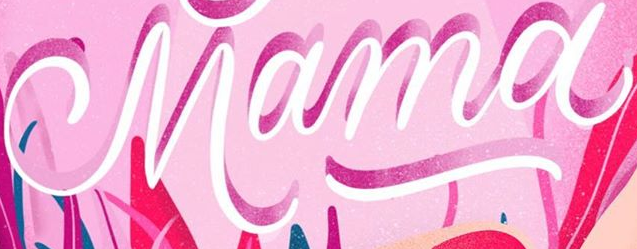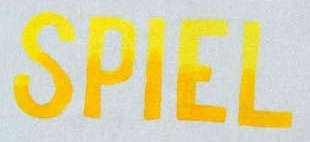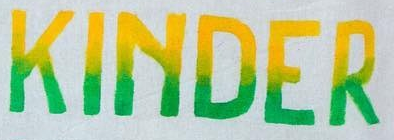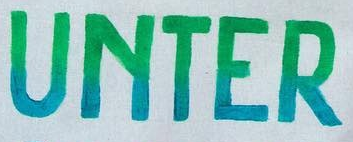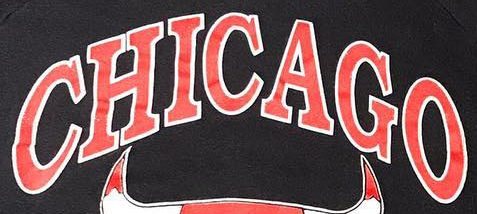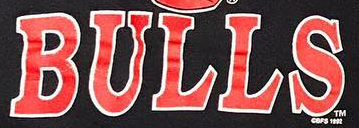Read the text from these images in sequence, separated by a semicolon. Mama; SPIEL; KINDER; UNTER; CHICAGO; BULLS 